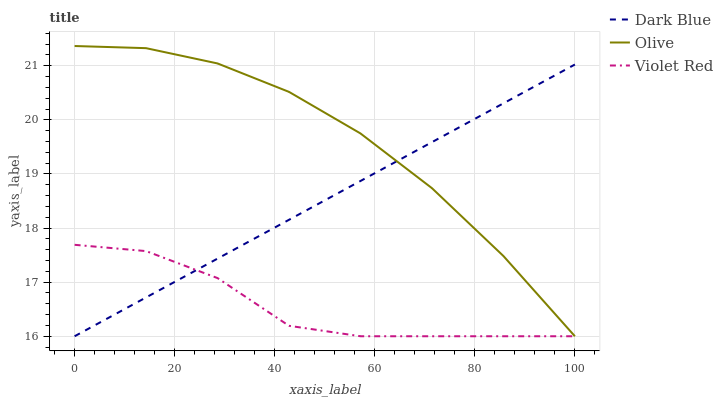Does Violet Red have the minimum area under the curve?
Answer yes or no. Yes. Does Olive have the maximum area under the curve?
Answer yes or no. Yes. Does Dark Blue have the minimum area under the curve?
Answer yes or no. No. Does Dark Blue have the maximum area under the curve?
Answer yes or no. No. Is Dark Blue the smoothest?
Answer yes or no. Yes. Is Violet Red the roughest?
Answer yes or no. Yes. Is Violet Red the smoothest?
Answer yes or no. No. Is Dark Blue the roughest?
Answer yes or no. No. Does Olive have the lowest value?
Answer yes or no. Yes. Does Olive have the highest value?
Answer yes or no. Yes. Does Dark Blue have the highest value?
Answer yes or no. No. Does Violet Red intersect Olive?
Answer yes or no. Yes. Is Violet Red less than Olive?
Answer yes or no. No. Is Violet Red greater than Olive?
Answer yes or no. No. 